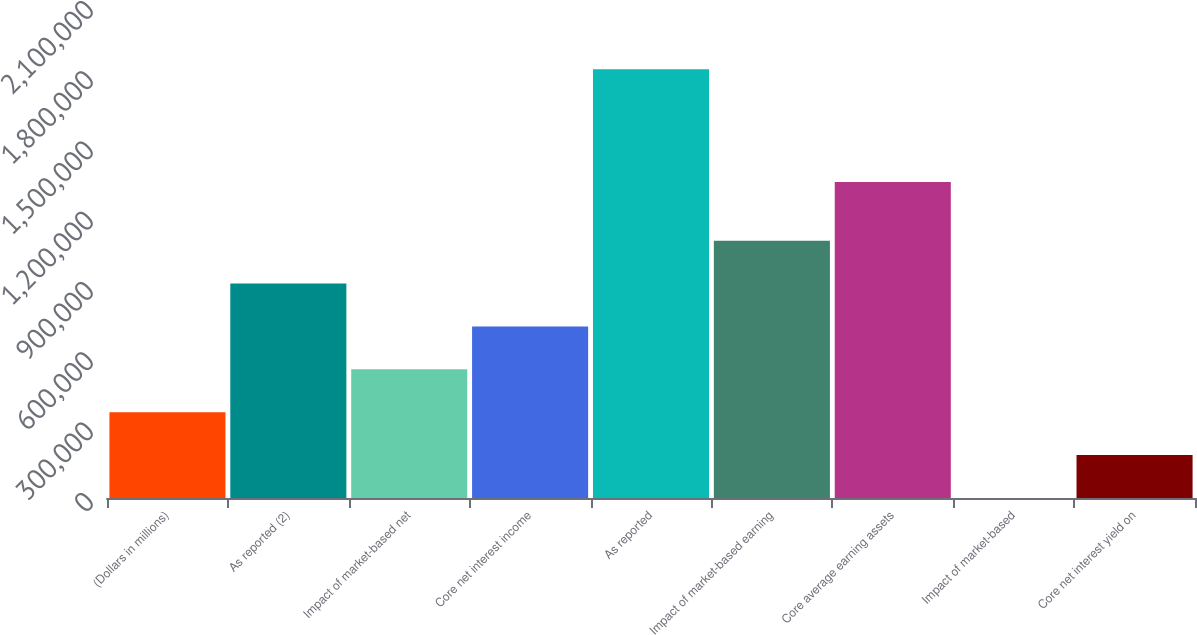Convert chart. <chart><loc_0><loc_0><loc_500><loc_500><bar_chart><fcel>(Dollars in millions)<fcel>As reported (2)<fcel>Impact of market-based net<fcel>Core net interest income<fcel>As reported<fcel>Impact of market-based earning<fcel>Core average earning assets<fcel>Impact of market-based<fcel>Core net interest yield on<nl><fcel>366039<fcel>915097<fcel>549058<fcel>732077<fcel>1.83019e+06<fcel>1.09812e+06<fcel>1.34882e+06<fcel>0.49<fcel>183020<nl></chart> 